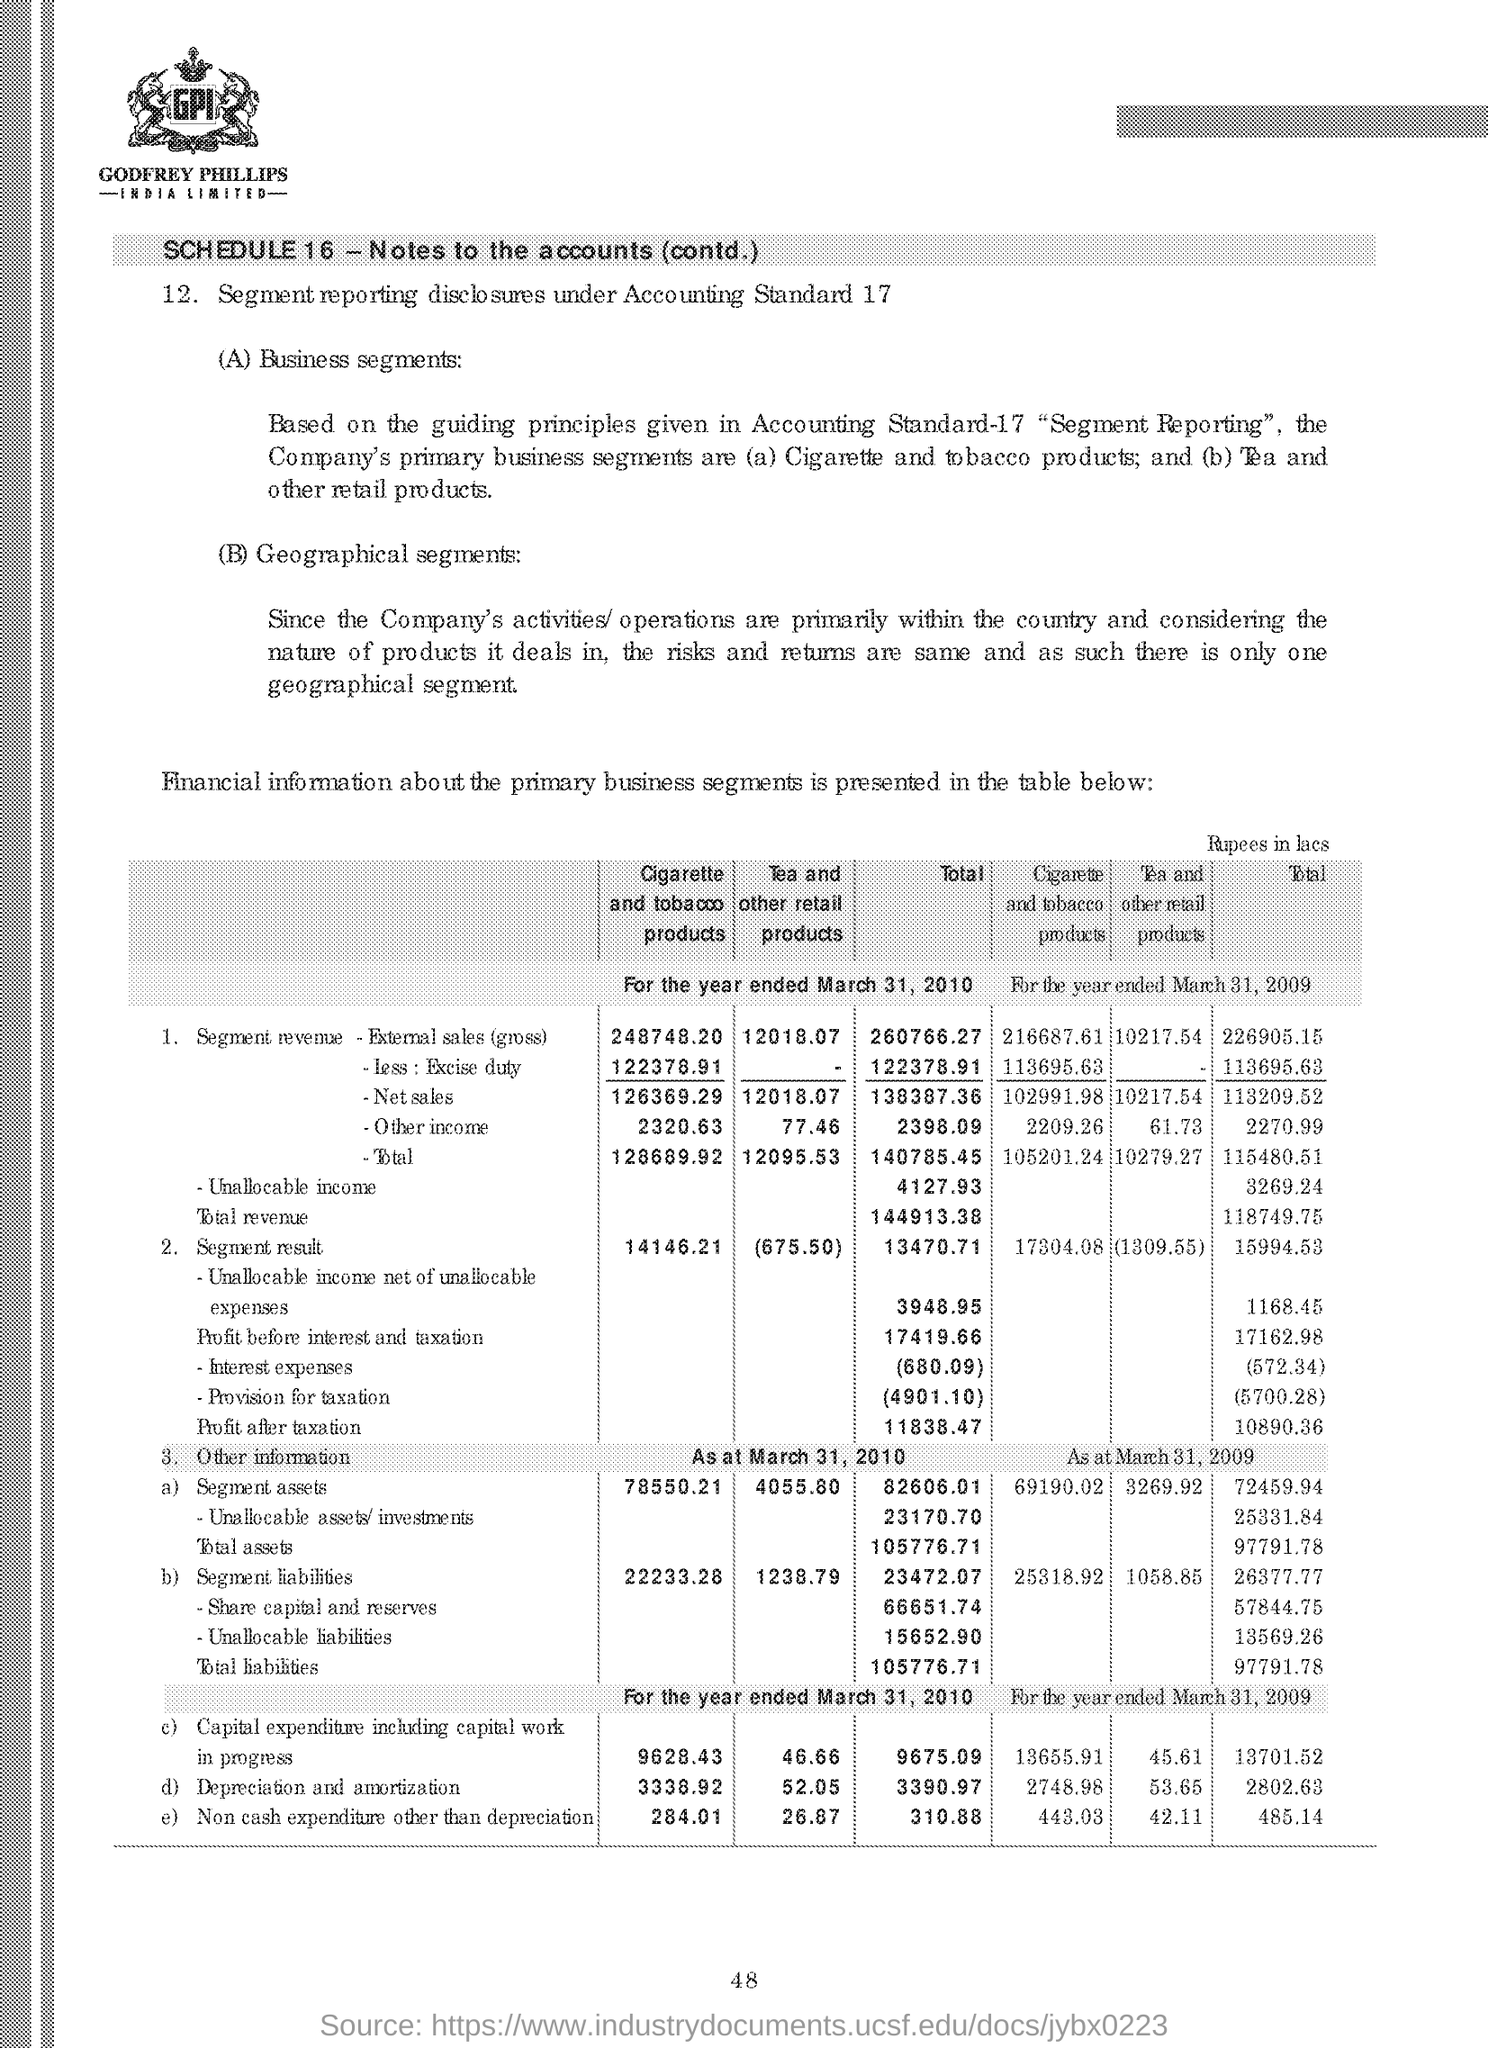Draw attention to some important aspects in this diagram. The total revenue for the segment for the year ended March 31, 2010 was $144,913.38. The total non-cash expenditure for the year ended March 31, 2010, excluding depreciation, was $310.88. Under the accounting standard, AS-17, segment reporting disclosures are required. The segment revenue from external sales of cigarette and tobacco products for the year ended March 31, 2010 was $248,748.20. The total non-cash expenditure, except for depreciation, for the year ended March 31, 2009, was 485.14. 